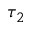<formula> <loc_0><loc_0><loc_500><loc_500>\tau _ { 2 }</formula> 